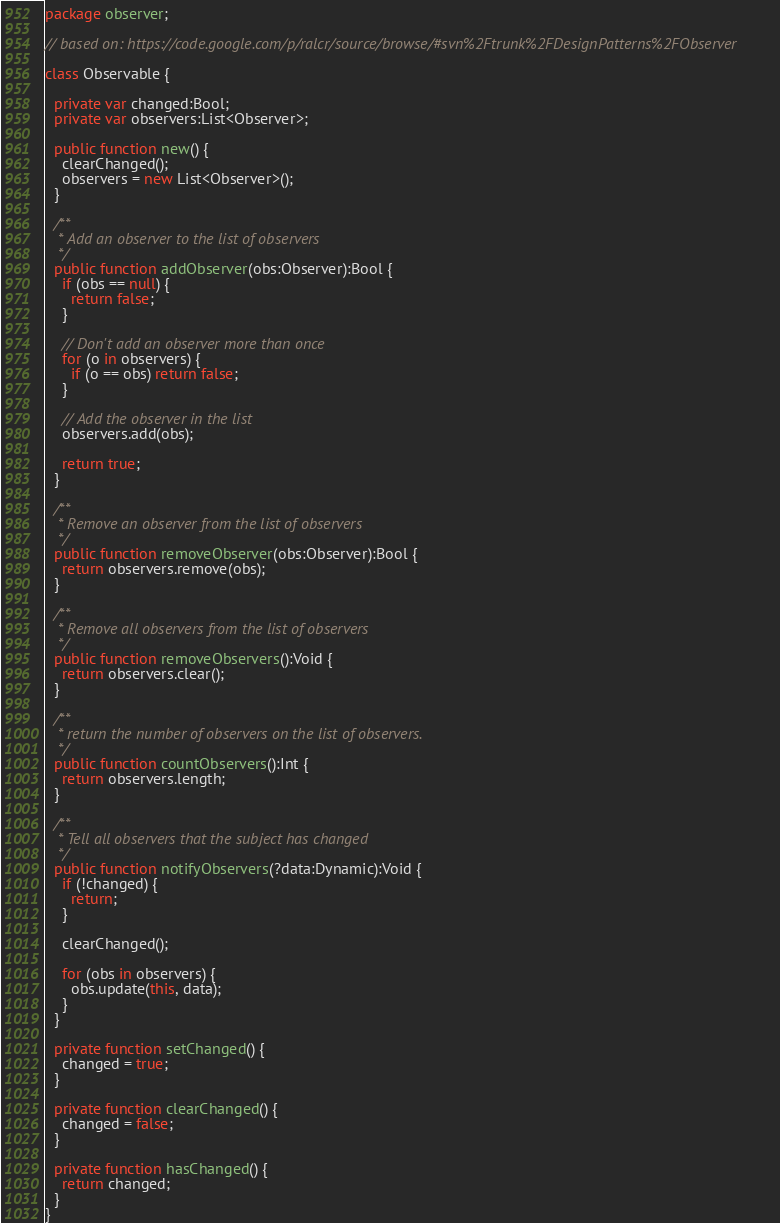<code> <loc_0><loc_0><loc_500><loc_500><_Haxe_>package observer;

// based on: https://code.google.com/p/ralcr/source/browse/#svn%2Ftrunk%2FDesignPatterns%2FObserver

class Observable {

  private var changed:Bool;
  private var observers:List<Observer>;

  public function new() {
    clearChanged();
    observers = new List<Observer>();
  }

  /**
   * Add an observer to the list of observers
   */
  public function addObserver(obs:Observer):Bool {
    if (obs == null) {
      return false;
    }

    // Don't add an observer more than once
    for (o in observers) {
      if (o == obs) return false;
    }

    // Add the observer in the list
    observers.add(obs);

    return true;
  }

  /**
   * Remove an observer from the list of observers
   */
  public function removeObserver(obs:Observer):Bool {
    return observers.remove(obs);
  }

  /**
   * Remove all observers from the list of observers
   */
  public function removeObservers():Void {
    return observers.clear();
  }

  /**
   * return the number of observers on the list of observers.
   */
  public function countObservers():Int {
    return observers.length;
  }

  /**
   * Tell all observers that the subject has changed
   */
  public function notifyObservers(?data:Dynamic):Void {
    if (!changed) {
      return;
    }

    clearChanged();

    for (obs in observers) {
      obs.update(this, data);
    }
  }

  private function setChanged() {
    changed = true;
  }

  private function clearChanged() {
    changed = false;
  }

  private function hasChanged() {
    return changed;
  }
}
</code> 